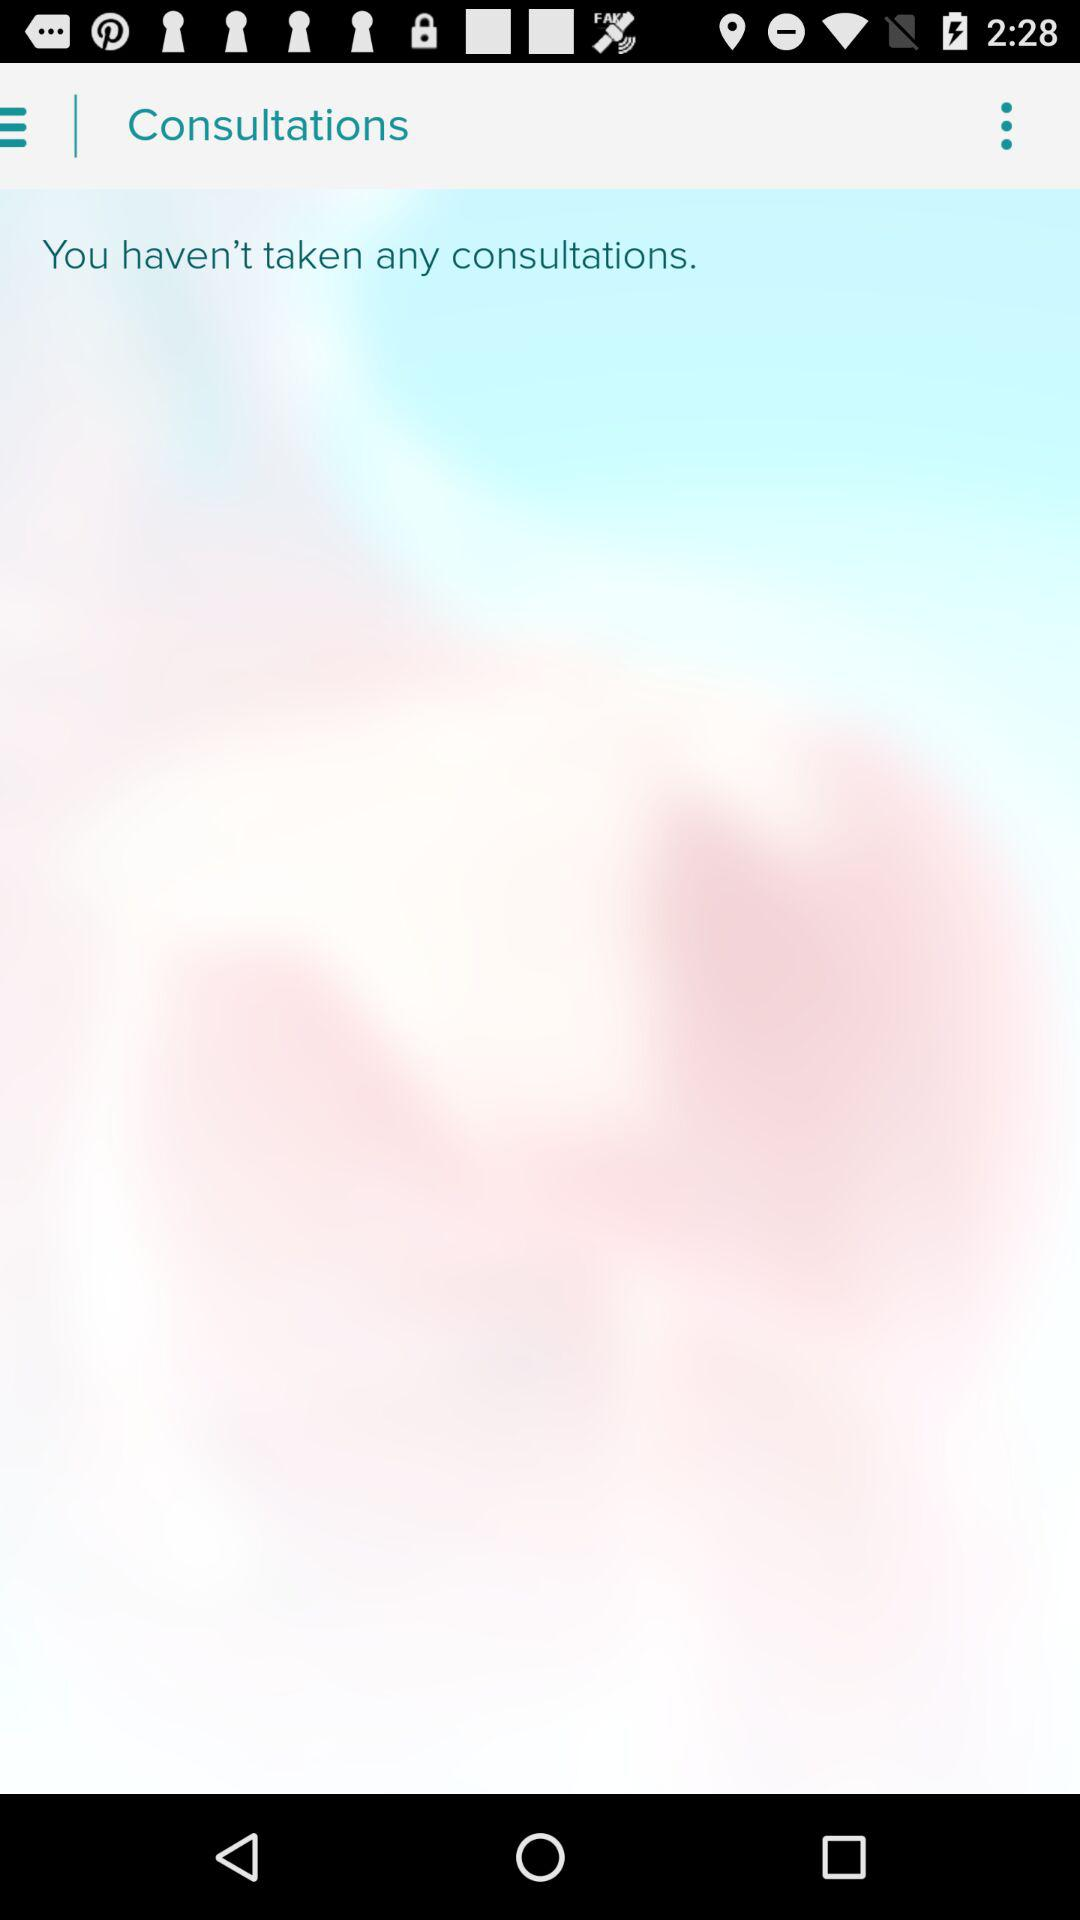How many consultations have I taken?
Answer the question using a single word or phrase. 0 